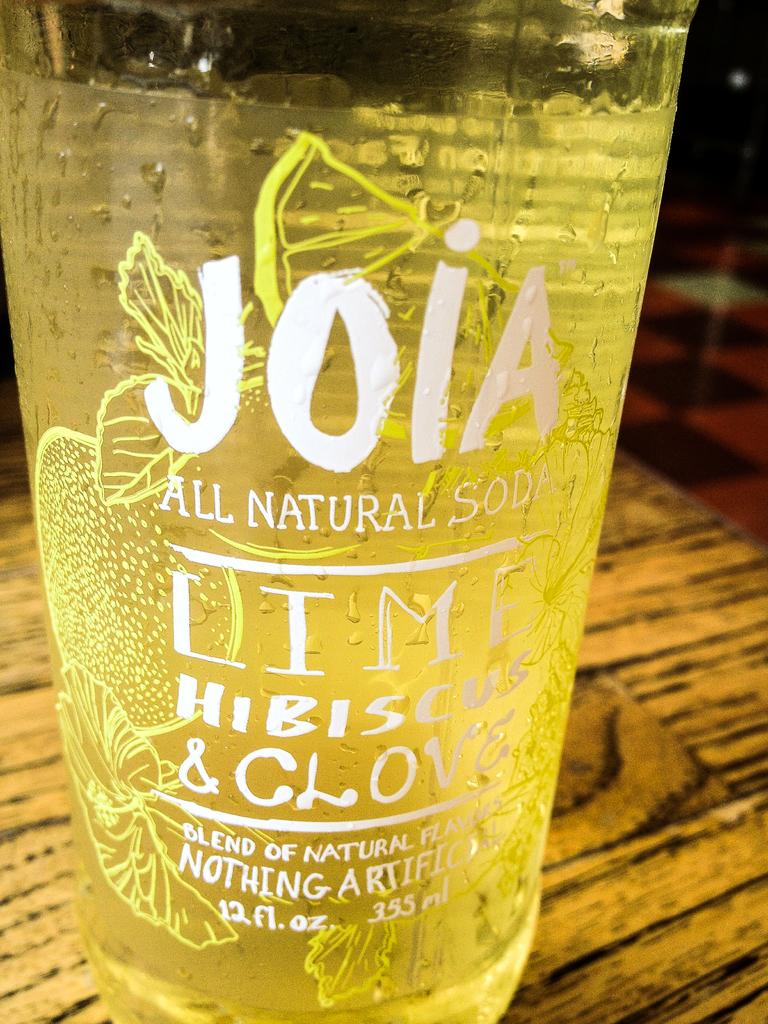Is there artificial flavoring in this drink?
Offer a very short reply. No. What fruit is this drink flavored with?
Make the answer very short. Lime. 